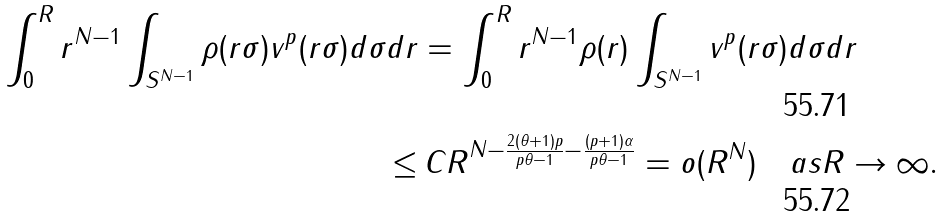Convert formula to latex. <formula><loc_0><loc_0><loc_500><loc_500>\int _ { 0 } ^ { R } r ^ { N - 1 } \int _ { S ^ { N - 1 } } \rho ( r \sigma ) v ^ { p } ( r \sigma ) d \sigma d r & = \int _ { 0 } ^ { R } r ^ { N - 1 } \rho ( r ) \int _ { S ^ { N - 1 } } v ^ { p } ( r \sigma ) d \sigma d r \\ \leq & \, C R ^ { N - \frac { 2 ( \theta + 1 ) p } { p \theta - 1 } - \frac { ( p + 1 ) \alpha } { p \theta - 1 } } = o ( R ^ { N } ) \quad a s R \to \infty .</formula> 